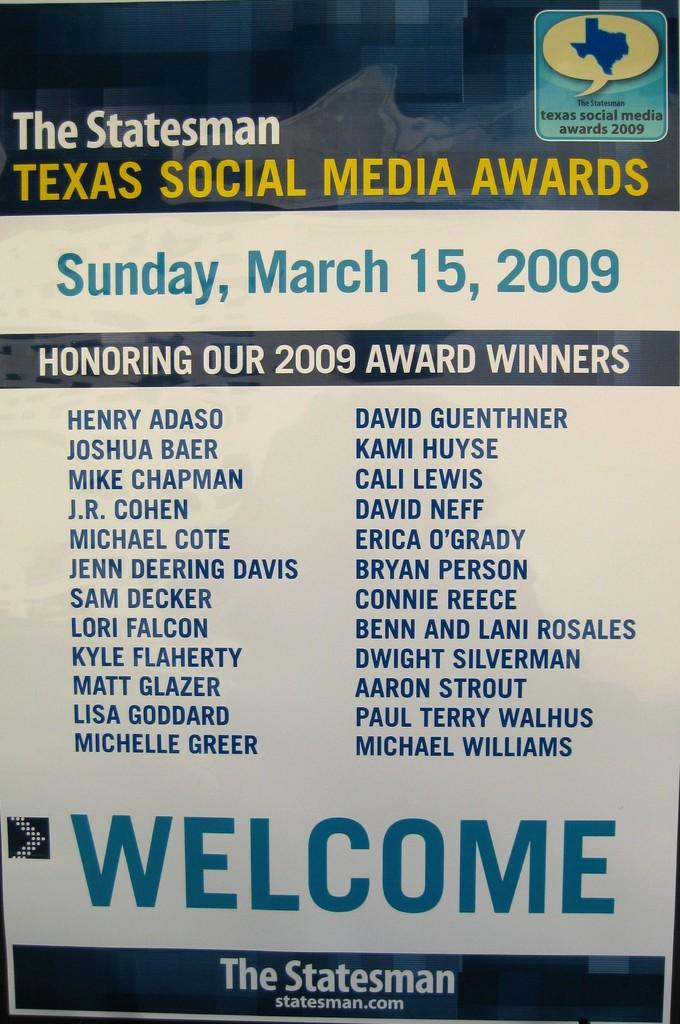<image>
Render a clear and concise summary of the photo. A welcome pamphlet to the Texas Social Media Awards. 